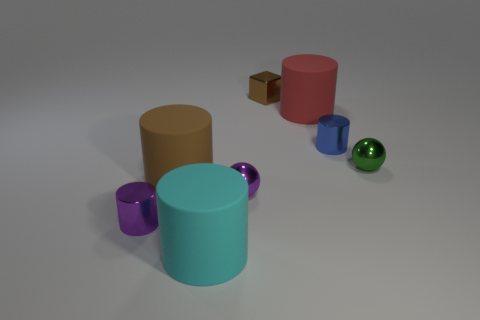There is another metal thing that is the same shape as the green shiny thing; what is its color?
Provide a short and direct response. Purple. Does the sphere on the right side of the big red matte thing have the same color as the rubber cylinder left of the cyan rubber cylinder?
Provide a short and direct response. No. Is the number of purple metallic objects that are on the right side of the big red rubber cylinder greater than the number of big brown matte cylinders?
Ensure brevity in your answer.  No. How many other objects are the same size as the purple metal ball?
Your response must be concise. 4. What number of objects are in front of the red matte cylinder and right of the block?
Give a very brief answer. 2. Are the brown thing in front of the green thing and the small blue thing made of the same material?
Your response must be concise. No. What shape is the large matte thing that is in front of the tiny cylinder that is in front of the tiny purple shiny object that is on the right side of the big cyan rubber thing?
Make the answer very short. Cylinder. Are there an equal number of large matte objects to the right of the small blue cylinder and small shiny objects that are behind the brown cylinder?
Provide a succinct answer. No. What color is the cylinder that is the same size as the blue shiny object?
Provide a succinct answer. Purple. How many small objects are brown rubber blocks or cylinders?
Offer a terse response. 2. 